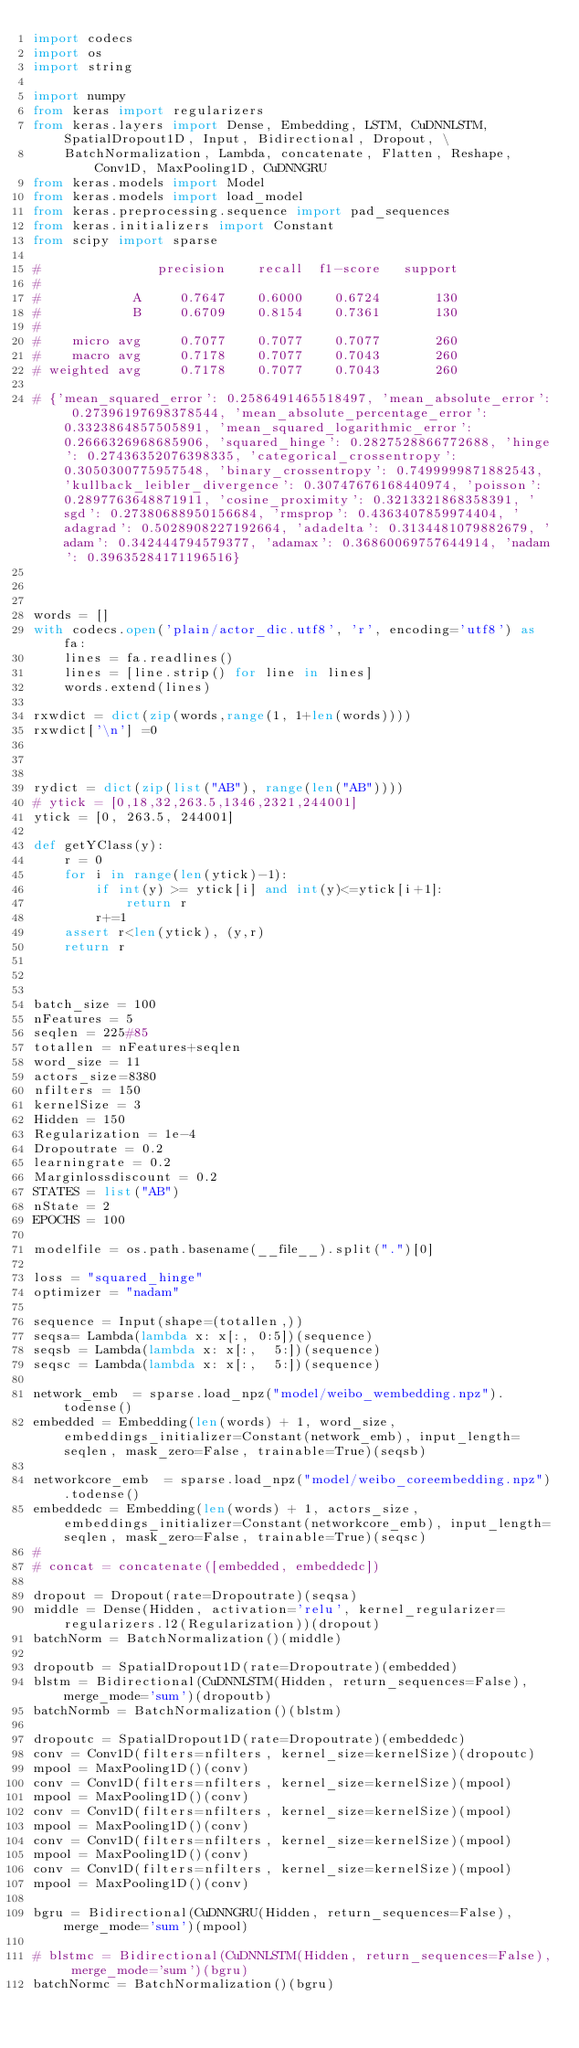Convert code to text. <code><loc_0><loc_0><loc_500><loc_500><_Python_>import codecs
import os
import string

import numpy
from keras import regularizers
from keras.layers import Dense, Embedding, LSTM, CuDNNLSTM, SpatialDropout1D, Input, Bidirectional, Dropout, \
    BatchNormalization, Lambda, concatenate, Flatten, Reshape, Conv1D, MaxPooling1D, CuDNNGRU
from keras.models import Model
from keras.models import load_model
from keras.preprocessing.sequence import pad_sequences
from keras.initializers import Constant
from scipy import sparse

#               precision    recall  f1-score   support
#
#            A     0.7647    0.6000    0.6724       130
#            B     0.6709    0.8154    0.7361       130
#
#    micro avg     0.7077    0.7077    0.7077       260
#    macro avg     0.7178    0.7077    0.7043       260
# weighted avg     0.7178    0.7077    0.7043       260

# {'mean_squared_error': 0.2586491465518497, 'mean_absolute_error': 0.27396197698378544, 'mean_absolute_percentage_error': 0.3323864857505891, 'mean_squared_logarithmic_error': 0.2666326968685906, 'squared_hinge': 0.2827528866772688, 'hinge': 0.27436352076398335, 'categorical_crossentropy': 0.3050300775957548, 'binary_crossentropy': 0.7499999871882543, 'kullback_leibler_divergence': 0.30747676168440974, 'poisson': 0.2897763648871911, 'cosine_proximity': 0.3213321868358391, 'sgd': 0.27380688950156684, 'rmsprop': 0.4363407859974404, 'adagrad': 0.5028908227192664, 'adadelta': 0.3134481079882679, 'adam': 0.342444794579377, 'adamax': 0.36860069757644914, 'nadam': 0.39635284171196516}



words = []
with codecs.open('plain/actor_dic.utf8', 'r', encoding='utf8') as fa:
    lines = fa.readlines()
    lines = [line.strip() for line in lines]
    words.extend(lines)

rxwdict = dict(zip(words,range(1, 1+len(words))))
rxwdict['\n'] =0



rydict = dict(zip(list("AB"), range(len("AB"))))
# ytick = [0,18,32,263.5,1346,2321,244001]
ytick = [0, 263.5, 244001]

def getYClass(y):
    r = 0
    for i in range(len(ytick)-1):
        if int(y) >= ytick[i] and int(y)<=ytick[i+1]:
            return r
        r+=1
    assert r<len(ytick), (y,r)
    return r



batch_size = 100
nFeatures = 5
seqlen = 225#85
totallen = nFeatures+seqlen
word_size = 11
actors_size=8380
nfilters = 150
kernelSize = 3
Hidden = 150
Regularization = 1e-4
Dropoutrate = 0.2
learningrate = 0.2
Marginlossdiscount = 0.2
STATES = list("AB")
nState = 2
EPOCHS = 100

modelfile = os.path.basename(__file__).split(".")[0]

loss = "squared_hinge"
optimizer = "nadam"

sequence = Input(shape=(totallen,))
seqsa= Lambda(lambda x: x[:, 0:5])(sequence)
seqsb = Lambda(lambda x: x[:,  5:])(sequence)
seqsc = Lambda(lambda x: x[:,  5:])(sequence)

network_emb  = sparse.load_npz("model/weibo_wembedding.npz").todense()
embedded = Embedding(len(words) + 1, word_size, embeddings_initializer=Constant(network_emb), input_length=seqlen, mask_zero=False, trainable=True)(seqsb)

networkcore_emb  = sparse.load_npz("model/weibo_coreembedding.npz").todense()
embeddedc = Embedding(len(words) + 1, actors_size, embeddings_initializer=Constant(networkcore_emb), input_length=seqlen, mask_zero=False, trainable=True)(seqsc)
#
# concat = concatenate([embedded, embeddedc])

dropout = Dropout(rate=Dropoutrate)(seqsa)
middle = Dense(Hidden, activation='relu', kernel_regularizer=regularizers.l2(Regularization))(dropout)
batchNorm = BatchNormalization()(middle)

dropoutb = SpatialDropout1D(rate=Dropoutrate)(embedded)
blstm = Bidirectional(CuDNNLSTM(Hidden, return_sequences=False), merge_mode='sum')(dropoutb)
batchNormb = BatchNormalization()(blstm)

dropoutc = SpatialDropout1D(rate=Dropoutrate)(embeddedc)
conv = Conv1D(filters=nfilters, kernel_size=kernelSize)(dropoutc)
mpool = MaxPooling1D()(conv)
conv = Conv1D(filters=nfilters, kernel_size=kernelSize)(mpool)
mpool = MaxPooling1D()(conv)
conv = Conv1D(filters=nfilters, kernel_size=kernelSize)(mpool)
mpool = MaxPooling1D()(conv)
conv = Conv1D(filters=nfilters, kernel_size=kernelSize)(mpool)
mpool = MaxPooling1D()(conv)
conv = Conv1D(filters=nfilters, kernel_size=kernelSize)(mpool)
mpool = MaxPooling1D()(conv)

bgru = Bidirectional(CuDNNGRU(Hidden, return_sequences=False), merge_mode='sum')(mpool)

# blstmc = Bidirectional(CuDNNLSTM(Hidden, return_sequences=False), merge_mode='sum')(bgru)
batchNormc = BatchNormalization()(bgru)
</code> 